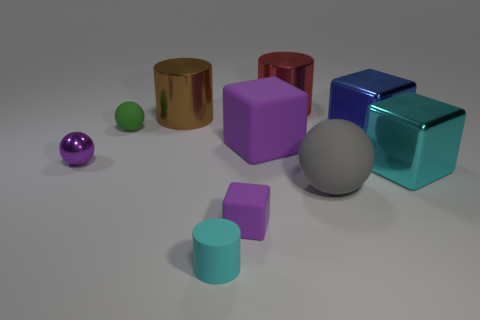There is another metal thing that is the same shape as the large brown metal thing; what is its size?
Offer a very short reply. Large. Is the color of the large matte block the same as the metallic object that is left of the brown metallic thing?
Provide a short and direct response. Yes. There is a gray rubber object; is it the same size as the rubber ball to the left of the big brown shiny object?
Make the answer very short. No. Are there any gray metallic blocks that have the same size as the red object?
Keep it short and to the point. No. How many things are either big blue metal objects or small purple balls?
Offer a terse response. 2. Is the size of the sphere to the right of the large purple matte thing the same as the cyan object that is on the left side of the large red cylinder?
Provide a short and direct response. No. Are there any red metallic things that have the same shape as the tiny purple rubber thing?
Keep it short and to the point. No. Are there fewer shiny cylinders that are in front of the big gray rubber sphere than red cubes?
Your answer should be very brief. No. Is the blue thing the same shape as the small purple metallic thing?
Give a very brief answer. No. There is a purple object that is left of the rubber cylinder; what is its size?
Offer a very short reply. Small. 